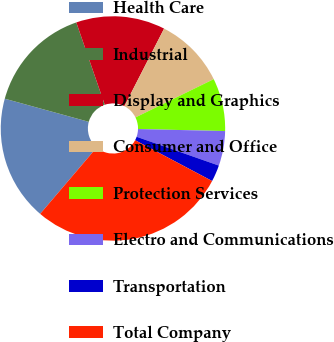<chart> <loc_0><loc_0><loc_500><loc_500><pie_chart><fcel>Health Care<fcel>Industrial<fcel>Display and Graphics<fcel>Consumer and Office<fcel>Protection Services<fcel>Electro and Communications<fcel>Transportation<fcel>Total Company<nl><fcel>18.04%<fcel>15.43%<fcel>12.83%<fcel>10.22%<fcel>7.61%<fcel>5.0%<fcel>2.39%<fcel>28.48%<nl></chart> 